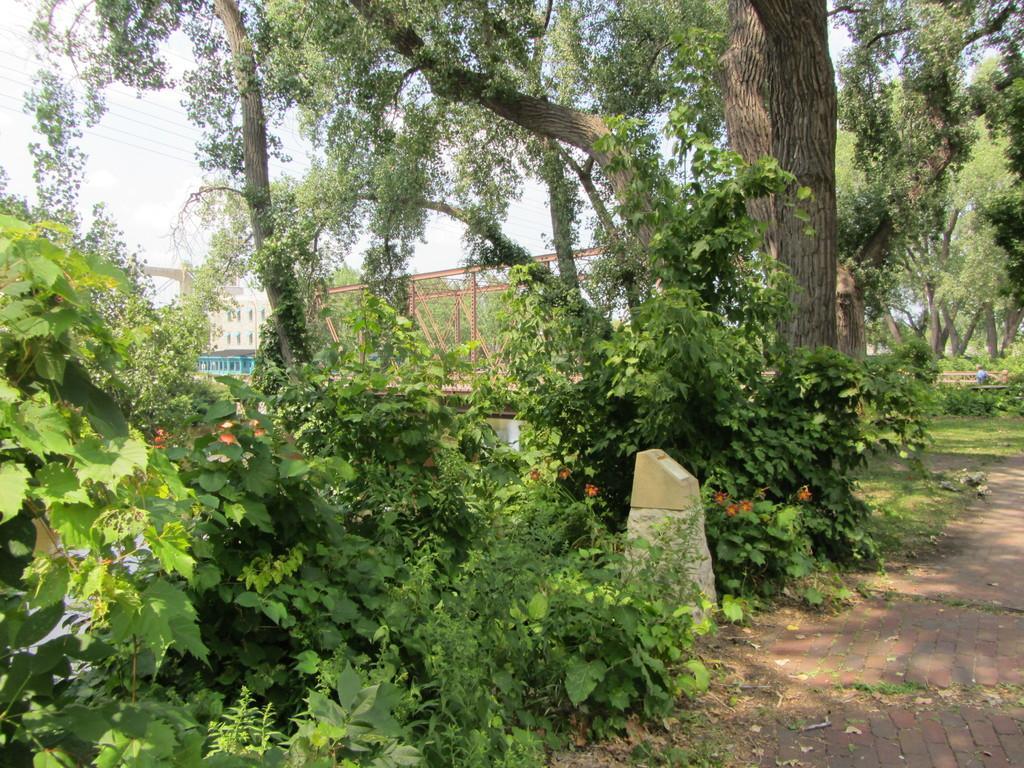Could you give a brief overview of what you see in this image? In this picture, there are many plants and trees. At the bottom of the picture, we see the road. In the background, we see a building in white color and we even see an iron bridge. In the left top of the picture, we see the sky and the wires. This picture is clicked in the garden. 